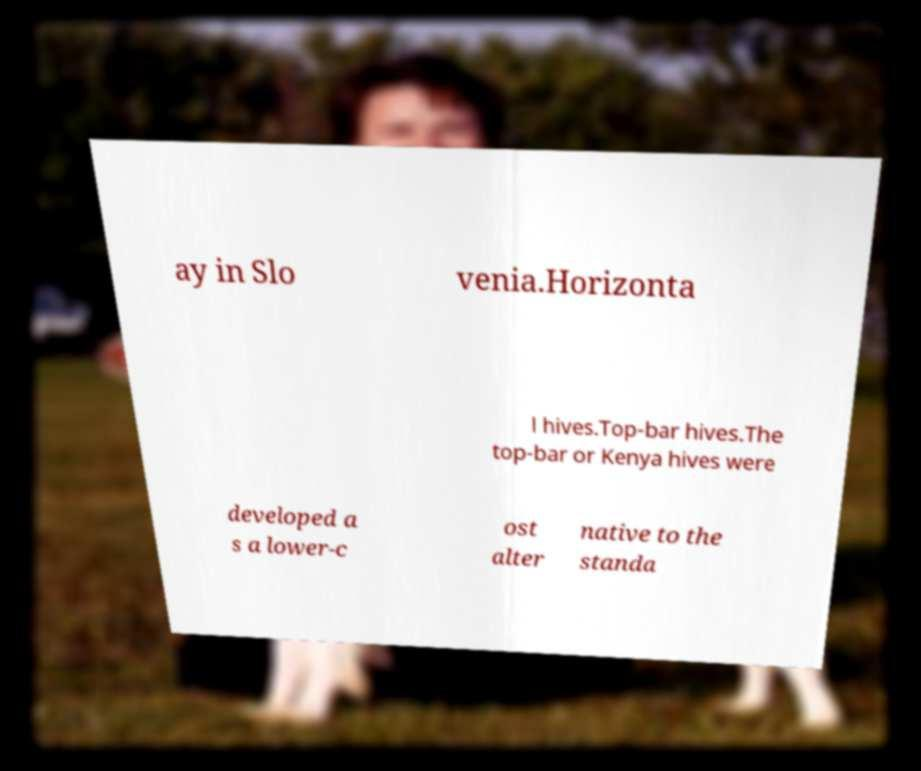Please read and relay the text visible in this image. What does it say? ay in Slo venia.Horizonta l hives.Top-bar hives.The top-bar or Kenya hives were developed a s a lower-c ost alter native to the standa 